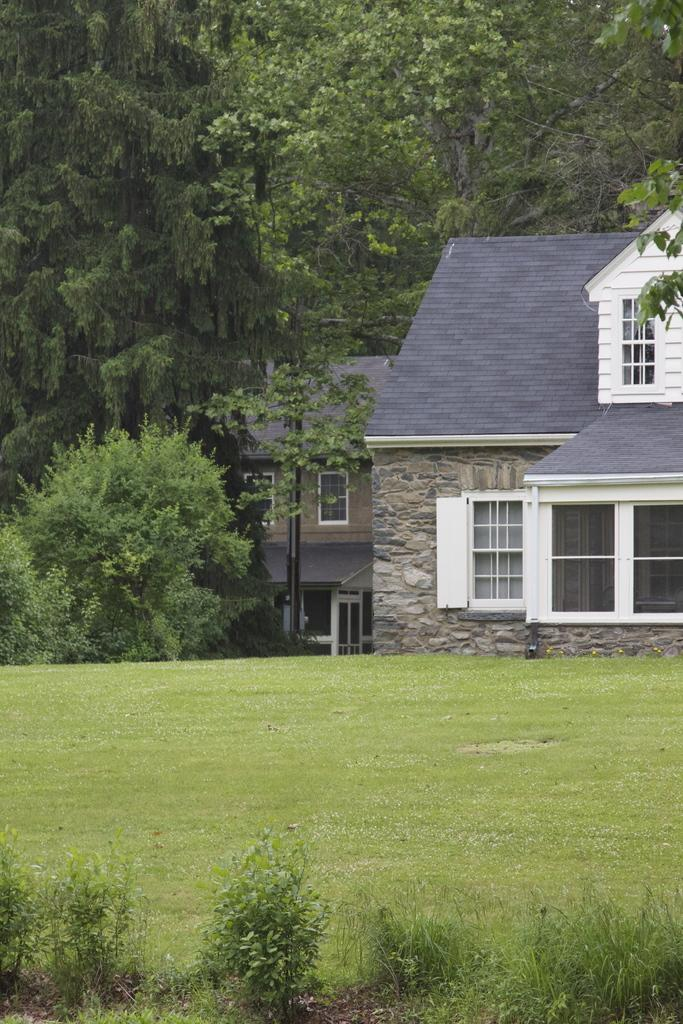How many houses can be seen in the image? There are two houses in the image. What is the ground like in front of the houses? The ground in front of the houses is covered with greenery. What type of vegetation is present in front of the houses? There are plants in front of the houses. What can be seen in the background of the image? There are trees in the background of the image. How many jellyfish are swimming in the front yard of the houses in the image? There are no jellyfish present in the image; the front yard is covered with greenery and plants. 